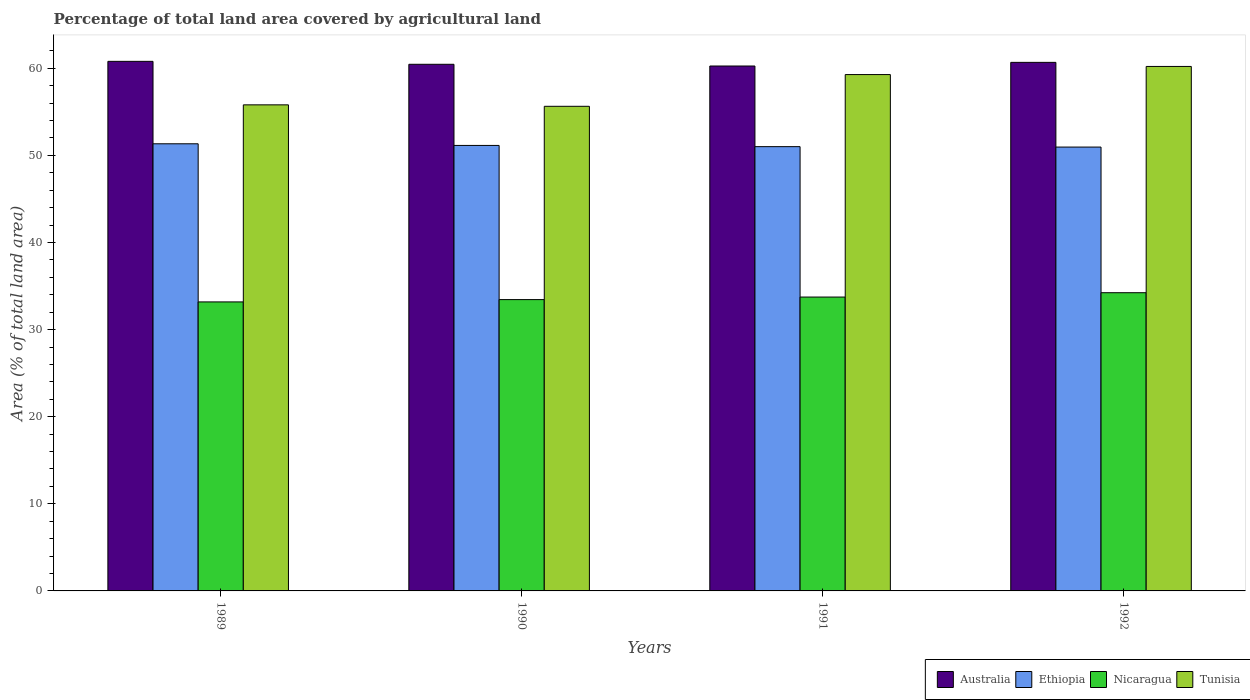How many different coloured bars are there?
Offer a terse response. 4. How many groups of bars are there?
Your response must be concise. 4. Are the number of bars per tick equal to the number of legend labels?
Your response must be concise. Yes. How many bars are there on the 4th tick from the left?
Provide a short and direct response. 4. How many bars are there on the 1st tick from the right?
Your answer should be very brief. 4. What is the label of the 1st group of bars from the left?
Provide a succinct answer. 1989. What is the percentage of agricultural land in Australia in 1991?
Give a very brief answer. 60.27. Across all years, what is the maximum percentage of agricultural land in Ethiopia?
Ensure brevity in your answer.  51.34. Across all years, what is the minimum percentage of agricultural land in Australia?
Offer a very short reply. 60.27. In which year was the percentage of agricultural land in Ethiopia maximum?
Ensure brevity in your answer.  1989. In which year was the percentage of agricultural land in Nicaragua minimum?
Provide a short and direct response. 1989. What is the total percentage of agricultural land in Nicaragua in the graph?
Offer a very short reply. 134.6. What is the difference between the percentage of agricultural land in Australia in 1989 and that in 1990?
Give a very brief answer. 0.34. What is the difference between the percentage of agricultural land in Tunisia in 1989 and the percentage of agricultural land in Ethiopia in 1990?
Make the answer very short. 4.66. What is the average percentage of agricultural land in Australia per year?
Your answer should be compact. 60.55. In the year 1991, what is the difference between the percentage of agricultural land in Nicaragua and percentage of agricultural land in Ethiopia?
Your answer should be very brief. -17.27. What is the ratio of the percentage of agricultural land in Tunisia in 1990 to that in 1991?
Give a very brief answer. 0.94. Is the difference between the percentage of agricultural land in Nicaragua in 1989 and 1990 greater than the difference between the percentage of agricultural land in Ethiopia in 1989 and 1990?
Your answer should be compact. No. What is the difference between the highest and the second highest percentage of agricultural land in Nicaragua?
Offer a very short reply. 0.5. What is the difference between the highest and the lowest percentage of agricultural land in Nicaragua?
Give a very brief answer. 1.06. Is the sum of the percentage of agricultural land in Australia in 1991 and 1992 greater than the maximum percentage of agricultural land in Ethiopia across all years?
Give a very brief answer. Yes. Is it the case that in every year, the sum of the percentage of agricultural land in Ethiopia and percentage of agricultural land in Australia is greater than the sum of percentage of agricultural land in Tunisia and percentage of agricultural land in Nicaragua?
Your answer should be compact. Yes. What does the 2nd bar from the left in 1990 represents?
Your response must be concise. Ethiopia. What does the 1st bar from the right in 1991 represents?
Provide a short and direct response. Tunisia. Are the values on the major ticks of Y-axis written in scientific E-notation?
Keep it short and to the point. No. Does the graph contain any zero values?
Offer a terse response. No. Does the graph contain grids?
Ensure brevity in your answer.  No. What is the title of the graph?
Offer a terse response. Percentage of total land area covered by agricultural land. What is the label or title of the X-axis?
Give a very brief answer. Years. What is the label or title of the Y-axis?
Keep it short and to the point. Area (% of total land area). What is the Area (% of total land area) in Australia in 1989?
Offer a terse response. 60.8. What is the Area (% of total land area) in Ethiopia in 1989?
Provide a short and direct response. 51.34. What is the Area (% of total land area) in Nicaragua in 1989?
Provide a short and direct response. 33.18. What is the Area (% of total land area) in Tunisia in 1989?
Make the answer very short. 55.81. What is the Area (% of total land area) of Australia in 1990?
Provide a succinct answer. 60.46. What is the Area (% of total land area) in Ethiopia in 1990?
Offer a very short reply. 51.15. What is the Area (% of total land area) of Nicaragua in 1990?
Give a very brief answer. 33.45. What is the Area (% of total land area) in Tunisia in 1990?
Your response must be concise. 55.64. What is the Area (% of total land area) in Australia in 1991?
Ensure brevity in your answer.  60.27. What is the Area (% of total land area) of Ethiopia in 1991?
Offer a very short reply. 51.01. What is the Area (% of total land area) of Nicaragua in 1991?
Give a very brief answer. 33.74. What is the Area (% of total land area) of Tunisia in 1991?
Your response must be concise. 59.28. What is the Area (% of total land area) of Australia in 1992?
Your response must be concise. 60.68. What is the Area (% of total land area) in Ethiopia in 1992?
Provide a succinct answer. 50.96. What is the Area (% of total land area) of Nicaragua in 1992?
Provide a succinct answer. 34.24. What is the Area (% of total land area) of Tunisia in 1992?
Make the answer very short. 60.21. Across all years, what is the maximum Area (% of total land area) of Australia?
Provide a succinct answer. 60.8. Across all years, what is the maximum Area (% of total land area) of Ethiopia?
Keep it short and to the point. 51.34. Across all years, what is the maximum Area (% of total land area) in Nicaragua?
Provide a short and direct response. 34.24. Across all years, what is the maximum Area (% of total land area) of Tunisia?
Your answer should be very brief. 60.21. Across all years, what is the minimum Area (% of total land area) of Australia?
Your answer should be very brief. 60.27. Across all years, what is the minimum Area (% of total land area) of Ethiopia?
Offer a very short reply. 50.96. Across all years, what is the minimum Area (% of total land area) in Nicaragua?
Make the answer very short. 33.18. Across all years, what is the minimum Area (% of total land area) in Tunisia?
Your answer should be compact. 55.64. What is the total Area (% of total land area) of Australia in the graph?
Your response must be concise. 242.21. What is the total Area (% of total land area) of Ethiopia in the graph?
Provide a succinct answer. 204.45. What is the total Area (% of total land area) in Nicaragua in the graph?
Offer a very short reply. 134.6. What is the total Area (% of total land area) of Tunisia in the graph?
Give a very brief answer. 230.94. What is the difference between the Area (% of total land area) of Australia in 1989 and that in 1990?
Offer a very short reply. 0.34. What is the difference between the Area (% of total land area) of Ethiopia in 1989 and that in 1990?
Provide a short and direct response. 0.19. What is the difference between the Area (% of total land area) in Nicaragua in 1989 and that in 1990?
Keep it short and to the point. -0.27. What is the difference between the Area (% of total land area) in Tunisia in 1989 and that in 1990?
Your answer should be compact. 0.17. What is the difference between the Area (% of total land area) in Australia in 1989 and that in 1991?
Ensure brevity in your answer.  0.53. What is the difference between the Area (% of total land area) of Ethiopia in 1989 and that in 1991?
Your answer should be compact. 0.33. What is the difference between the Area (% of total land area) of Nicaragua in 1989 and that in 1991?
Your response must be concise. -0.56. What is the difference between the Area (% of total land area) in Tunisia in 1989 and that in 1991?
Offer a very short reply. -3.48. What is the difference between the Area (% of total land area) of Australia in 1989 and that in 1992?
Your response must be concise. 0.12. What is the difference between the Area (% of total land area) in Ethiopia in 1989 and that in 1992?
Provide a succinct answer. 0.38. What is the difference between the Area (% of total land area) of Nicaragua in 1989 and that in 1992?
Provide a succinct answer. -1.06. What is the difference between the Area (% of total land area) of Tunisia in 1989 and that in 1992?
Your answer should be compact. -4.41. What is the difference between the Area (% of total land area) of Australia in 1990 and that in 1991?
Keep it short and to the point. 0.2. What is the difference between the Area (% of total land area) of Ethiopia in 1990 and that in 1991?
Offer a very short reply. 0.14. What is the difference between the Area (% of total land area) in Nicaragua in 1990 and that in 1991?
Offer a very short reply. -0.29. What is the difference between the Area (% of total land area) of Tunisia in 1990 and that in 1991?
Make the answer very short. -3.64. What is the difference between the Area (% of total land area) of Australia in 1990 and that in 1992?
Your response must be concise. -0.22. What is the difference between the Area (% of total land area) in Ethiopia in 1990 and that in 1992?
Your answer should be compact. 0.19. What is the difference between the Area (% of total land area) of Nicaragua in 1990 and that in 1992?
Ensure brevity in your answer.  -0.79. What is the difference between the Area (% of total land area) of Tunisia in 1990 and that in 1992?
Keep it short and to the point. -4.58. What is the difference between the Area (% of total land area) of Australia in 1991 and that in 1992?
Provide a succinct answer. -0.42. What is the difference between the Area (% of total land area) of Ethiopia in 1991 and that in 1992?
Offer a terse response. 0.05. What is the difference between the Area (% of total land area) in Nicaragua in 1991 and that in 1992?
Offer a terse response. -0.5. What is the difference between the Area (% of total land area) of Tunisia in 1991 and that in 1992?
Offer a very short reply. -0.93. What is the difference between the Area (% of total land area) in Australia in 1989 and the Area (% of total land area) in Ethiopia in 1990?
Offer a very short reply. 9.65. What is the difference between the Area (% of total land area) in Australia in 1989 and the Area (% of total land area) in Nicaragua in 1990?
Give a very brief answer. 27.35. What is the difference between the Area (% of total land area) of Australia in 1989 and the Area (% of total land area) of Tunisia in 1990?
Your response must be concise. 5.16. What is the difference between the Area (% of total land area) of Ethiopia in 1989 and the Area (% of total land area) of Nicaragua in 1990?
Provide a succinct answer. 17.89. What is the difference between the Area (% of total land area) of Ethiopia in 1989 and the Area (% of total land area) of Tunisia in 1990?
Offer a very short reply. -4.3. What is the difference between the Area (% of total land area) of Nicaragua in 1989 and the Area (% of total land area) of Tunisia in 1990?
Provide a short and direct response. -22.46. What is the difference between the Area (% of total land area) of Australia in 1989 and the Area (% of total land area) of Ethiopia in 1991?
Your response must be concise. 9.79. What is the difference between the Area (% of total land area) in Australia in 1989 and the Area (% of total land area) in Nicaragua in 1991?
Provide a short and direct response. 27.06. What is the difference between the Area (% of total land area) of Australia in 1989 and the Area (% of total land area) of Tunisia in 1991?
Give a very brief answer. 1.52. What is the difference between the Area (% of total land area) in Ethiopia in 1989 and the Area (% of total land area) in Nicaragua in 1991?
Your answer should be compact. 17.6. What is the difference between the Area (% of total land area) of Ethiopia in 1989 and the Area (% of total land area) of Tunisia in 1991?
Your answer should be compact. -7.95. What is the difference between the Area (% of total land area) in Nicaragua in 1989 and the Area (% of total land area) in Tunisia in 1991?
Keep it short and to the point. -26.1. What is the difference between the Area (% of total land area) in Australia in 1989 and the Area (% of total land area) in Ethiopia in 1992?
Offer a very short reply. 9.84. What is the difference between the Area (% of total land area) of Australia in 1989 and the Area (% of total land area) of Nicaragua in 1992?
Give a very brief answer. 26.56. What is the difference between the Area (% of total land area) in Australia in 1989 and the Area (% of total land area) in Tunisia in 1992?
Offer a terse response. 0.58. What is the difference between the Area (% of total land area) of Ethiopia in 1989 and the Area (% of total land area) of Nicaragua in 1992?
Make the answer very short. 17.1. What is the difference between the Area (% of total land area) in Ethiopia in 1989 and the Area (% of total land area) in Tunisia in 1992?
Keep it short and to the point. -8.88. What is the difference between the Area (% of total land area) in Nicaragua in 1989 and the Area (% of total land area) in Tunisia in 1992?
Give a very brief answer. -27.03. What is the difference between the Area (% of total land area) in Australia in 1990 and the Area (% of total land area) in Ethiopia in 1991?
Offer a very short reply. 9.45. What is the difference between the Area (% of total land area) in Australia in 1990 and the Area (% of total land area) in Nicaragua in 1991?
Your response must be concise. 26.72. What is the difference between the Area (% of total land area) in Australia in 1990 and the Area (% of total land area) in Tunisia in 1991?
Offer a very short reply. 1.18. What is the difference between the Area (% of total land area) in Ethiopia in 1990 and the Area (% of total land area) in Nicaragua in 1991?
Provide a succinct answer. 17.41. What is the difference between the Area (% of total land area) in Ethiopia in 1990 and the Area (% of total land area) in Tunisia in 1991?
Your answer should be very brief. -8.14. What is the difference between the Area (% of total land area) of Nicaragua in 1990 and the Area (% of total land area) of Tunisia in 1991?
Your answer should be very brief. -25.83. What is the difference between the Area (% of total land area) in Australia in 1990 and the Area (% of total land area) in Ethiopia in 1992?
Provide a succinct answer. 9.5. What is the difference between the Area (% of total land area) in Australia in 1990 and the Area (% of total land area) in Nicaragua in 1992?
Offer a terse response. 26.22. What is the difference between the Area (% of total land area) in Australia in 1990 and the Area (% of total land area) in Tunisia in 1992?
Offer a terse response. 0.25. What is the difference between the Area (% of total land area) in Ethiopia in 1990 and the Area (% of total land area) in Nicaragua in 1992?
Keep it short and to the point. 16.91. What is the difference between the Area (% of total land area) of Ethiopia in 1990 and the Area (% of total land area) of Tunisia in 1992?
Your answer should be compact. -9.07. What is the difference between the Area (% of total land area) in Nicaragua in 1990 and the Area (% of total land area) in Tunisia in 1992?
Offer a very short reply. -26.77. What is the difference between the Area (% of total land area) in Australia in 1991 and the Area (% of total land area) in Ethiopia in 1992?
Keep it short and to the point. 9.31. What is the difference between the Area (% of total land area) of Australia in 1991 and the Area (% of total land area) of Nicaragua in 1992?
Ensure brevity in your answer.  26.03. What is the difference between the Area (% of total land area) of Ethiopia in 1991 and the Area (% of total land area) of Nicaragua in 1992?
Keep it short and to the point. 16.77. What is the difference between the Area (% of total land area) in Ethiopia in 1991 and the Area (% of total land area) in Tunisia in 1992?
Your answer should be very brief. -9.21. What is the difference between the Area (% of total land area) in Nicaragua in 1991 and the Area (% of total land area) in Tunisia in 1992?
Your answer should be very brief. -26.48. What is the average Area (% of total land area) of Australia per year?
Offer a terse response. 60.55. What is the average Area (% of total land area) of Ethiopia per year?
Offer a terse response. 51.11. What is the average Area (% of total land area) of Nicaragua per year?
Provide a succinct answer. 33.65. What is the average Area (% of total land area) in Tunisia per year?
Your answer should be very brief. 57.74. In the year 1989, what is the difference between the Area (% of total land area) in Australia and Area (% of total land area) in Ethiopia?
Provide a short and direct response. 9.46. In the year 1989, what is the difference between the Area (% of total land area) in Australia and Area (% of total land area) in Nicaragua?
Your response must be concise. 27.62. In the year 1989, what is the difference between the Area (% of total land area) in Australia and Area (% of total land area) in Tunisia?
Your response must be concise. 4.99. In the year 1989, what is the difference between the Area (% of total land area) in Ethiopia and Area (% of total land area) in Nicaragua?
Give a very brief answer. 18.15. In the year 1989, what is the difference between the Area (% of total land area) of Ethiopia and Area (% of total land area) of Tunisia?
Keep it short and to the point. -4.47. In the year 1989, what is the difference between the Area (% of total land area) in Nicaragua and Area (% of total land area) in Tunisia?
Provide a short and direct response. -22.62. In the year 1990, what is the difference between the Area (% of total land area) of Australia and Area (% of total land area) of Ethiopia?
Keep it short and to the point. 9.31. In the year 1990, what is the difference between the Area (% of total land area) in Australia and Area (% of total land area) in Nicaragua?
Provide a succinct answer. 27.01. In the year 1990, what is the difference between the Area (% of total land area) of Australia and Area (% of total land area) of Tunisia?
Your answer should be very brief. 4.82. In the year 1990, what is the difference between the Area (% of total land area) of Ethiopia and Area (% of total land area) of Nicaragua?
Provide a short and direct response. 17.7. In the year 1990, what is the difference between the Area (% of total land area) in Ethiopia and Area (% of total land area) in Tunisia?
Your answer should be compact. -4.49. In the year 1990, what is the difference between the Area (% of total land area) of Nicaragua and Area (% of total land area) of Tunisia?
Give a very brief answer. -22.19. In the year 1991, what is the difference between the Area (% of total land area) in Australia and Area (% of total land area) in Ethiopia?
Give a very brief answer. 9.26. In the year 1991, what is the difference between the Area (% of total land area) of Australia and Area (% of total land area) of Nicaragua?
Your answer should be compact. 26.53. In the year 1991, what is the difference between the Area (% of total land area) of Australia and Area (% of total land area) of Tunisia?
Give a very brief answer. 0.98. In the year 1991, what is the difference between the Area (% of total land area) of Ethiopia and Area (% of total land area) of Nicaragua?
Your answer should be compact. 17.27. In the year 1991, what is the difference between the Area (% of total land area) of Ethiopia and Area (% of total land area) of Tunisia?
Your answer should be compact. -8.28. In the year 1991, what is the difference between the Area (% of total land area) of Nicaragua and Area (% of total land area) of Tunisia?
Ensure brevity in your answer.  -25.54. In the year 1992, what is the difference between the Area (% of total land area) of Australia and Area (% of total land area) of Ethiopia?
Make the answer very short. 9.72. In the year 1992, what is the difference between the Area (% of total land area) in Australia and Area (% of total land area) in Nicaragua?
Your answer should be compact. 26.45. In the year 1992, what is the difference between the Area (% of total land area) in Australia and Area (% of total land area) in Tunisia?
Your answer should be very brief. 0.47. In the year 1992, what is the difference between the Area (% of total land area) of Ethiopia and Area (% of total land area) of Nicaragua?
Ensure brevity in your answer.  16.72. In the year 1992, what is the difference between the Area (% of total land area) in Ethiopia and Area (% of total land area) in Tunisia?
Provide a succinct answer. -9.26. In the year 1992, what is the difference between the Area (% of total land area) in Nicaragua and Area (% of total land area) in Tunisia?
Ensure brevity in your answer.  -25.98. What is the ratio of the Area (% of total land area) in Australia in 1989 to that in 1990?
Provide a succinct answer. 1.01. What is the ratio of the Area (% of total land area) of Ethiopia in 1989 to that in 1990?
Ensure brevity in your answer.  1. What is the ratio of the Area (% of total land area) in Nicaragua in 1989 to that in 1990?
Make the answer very short. 0.99. What is the ratio of the Area (% of total land area) in Australia in 1989 to that in 1991?
Provide a short and direct response. 1.01. What is the ratio of the Area (% of total land area) of Ethiopia in 1989 to that in 1991?
Provide a short and direct response. 1.01. What is the ratio of the Area (% of total land area) in Nicaragua in 1989 to that in 1991?
Give a very brief answer. 0.98. What is the ratio of the Area (% of total land area) of Tunisia in 1989 to that in 1991?
Provide a short and direct response. 0.94. What is the ratio of the Area (% of total land area) in Australia in 1989 to that in 1992?
Make the answer very short. 1. What is the ratio of the Area (% of total land area) in Ethiopia in 1989 to that in 1992?
Your answer should be very brief. 1.01. What is the ratio of the Area (% of total land area) in Nicaragua in 1989 to that in 1992?
Your answer should be very brief. 0.97. What is the ratio of the Area (% of total land area) in Tunisia in 1989 to that in 1992?
Give a very brief answer. 0.93. What is the ratio of the Area (% of total land area) in Australia in 1990 to that in 1991?
Give a very brief answer. 1. What is the ratio of the Area (% of total land area) of Ethiopia in 1990 to that in 1991?
Your response must be concise. 1. What is the ratio of the Area (% of total land area) in Nicaragua in 1990 to that in 1991?
Keep it short and to the point. 0.99. What is the ratio of the Area (% of total land area) in Tunisia in 1990 to that in 1991?
Provide a short and direct response. 0.94. What is the ratio of the Area (% of total land area) in Ethiopia in 1990 to that in 1992?
Your answer should be very brief. 1. What is the ratio of the Area (% of total land area) of Nicaragua in 1990 to that in 1992?
Give a very brief answer. 0.98. What is the ratio of the Area (% of total land area) of Tunisia in 1990 to that in 1992?
Provide a succinct answer. 0.92. What is the ratio of the Area (% of total land area) of Australia in 1991 to that in 1992?
Give a very brief answer. 0.99. What is the ratio of the Area (% of total land area) in Nicaragua in 1991 to that in 1992?
Offer a terse response. 0.99. What is the ratio of the Area (% of total land area) in Tunisia in 1991 to that in 1992?
Make the answer very short. 0.98. What is the difference between the highest and the second highest Area (% of total land area) in Australia?
Make the answer very short. 0.12. What is the difference between the highest and the second highest Area (% of total land area) in Ethiopia?
Your answer should be compact. 0.19. What is the difference between the highest and the second highest Area (% of total land area) in Nicaragua?
Ensure brevity in your answer.  0.5. What is the difference between the highest and the second highest Area (% of total land area) in Tunisia?
Ensure brevity in your answer.  0.93. What is the difference between the highest and the lowest Area (% of total land area) in Australia?
Offer a terse response. 0.53. What is the difference between the highest and the lowest Area (% of total land area) of Ethiopia?
Your answer should be compact. 0.38. What is the difference between the highest and the lowest Area (% of total land area) of Nicaragua?
Ensure brevity in your answer.  1.06. What is the difference between the highest and the lowest Area (% of total land area) of Tunisia?
Provide a short and direct response. 4.58. 